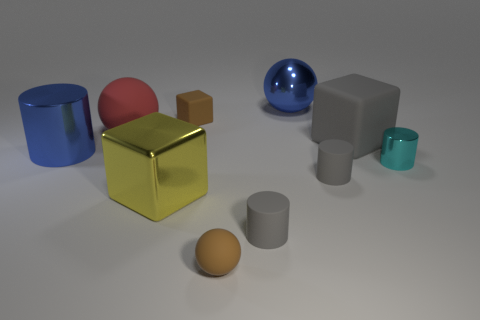Subtract all big balls. How many balls are left? 1 Subtract 1 blue cylinders. How many objects are left? 9 Subtract all spheres. How many objects are left? 7 Subtract 3 cubes. How many cubes are left? 0 Subtract all green balls. Subtract all purple blocks. How many balls are left? 3 Subtract all brown blocks. How many brown spheres are left? 1 Subtract all large things. Subtract all yellow shiny things. How many objects are left? 4 Add 2 blue objects. How many blue objects are left? 4 Add 1 cylinders. How many cylinders exist? 5 Subtract all blue cylinders. How many cylinders are left? 3 